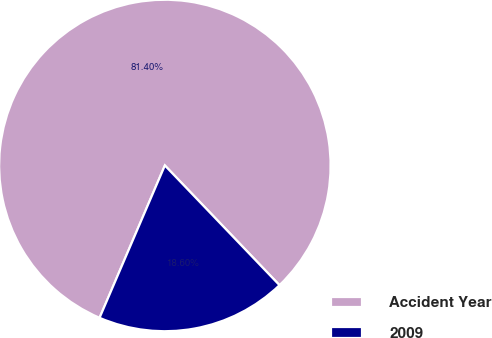Convert chart to OTSL. <chart><loc_0><loc_0><loc_500><loc_500><pie_chart><fcel>Accident Year<fcel>2009<nl><fcel>81.4%<fcel>18.6%<nl></chart> 